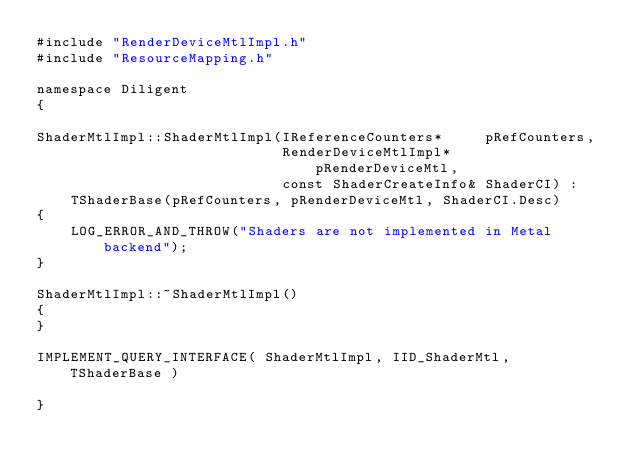Convert code to text. <code><loc_0><loc_0><loc_500><loc_500><_ObjectiveC_>#include "RenderDeviceMtlImpl.h"
#include "ResourceMapping.h"

namespace Diligent
{

ShaderMtlImpl::ShaderMtlImpl(IReferenceCounters*     pRefCounters,
                             RenderDeviceMtlImpl*    pRenderDeviceMtl,
                             const ShaderCreateInfo& ShaderCI) : 
    TShaderBase(pRefCounters, pRenderDeviceMtl, ShaderCI.Desc)
{
    LOG_ERROR_AND_THROW("Shaders are not implemented in Metal backend");
}

ShaderMtlImpl::~ShaderMtlImpl()
{
}

IMPLEMENT_QUERY_INTERFACE( ShaderMtlImpl, IID_ShaderMtl, TShaderBase )

}
</code> 